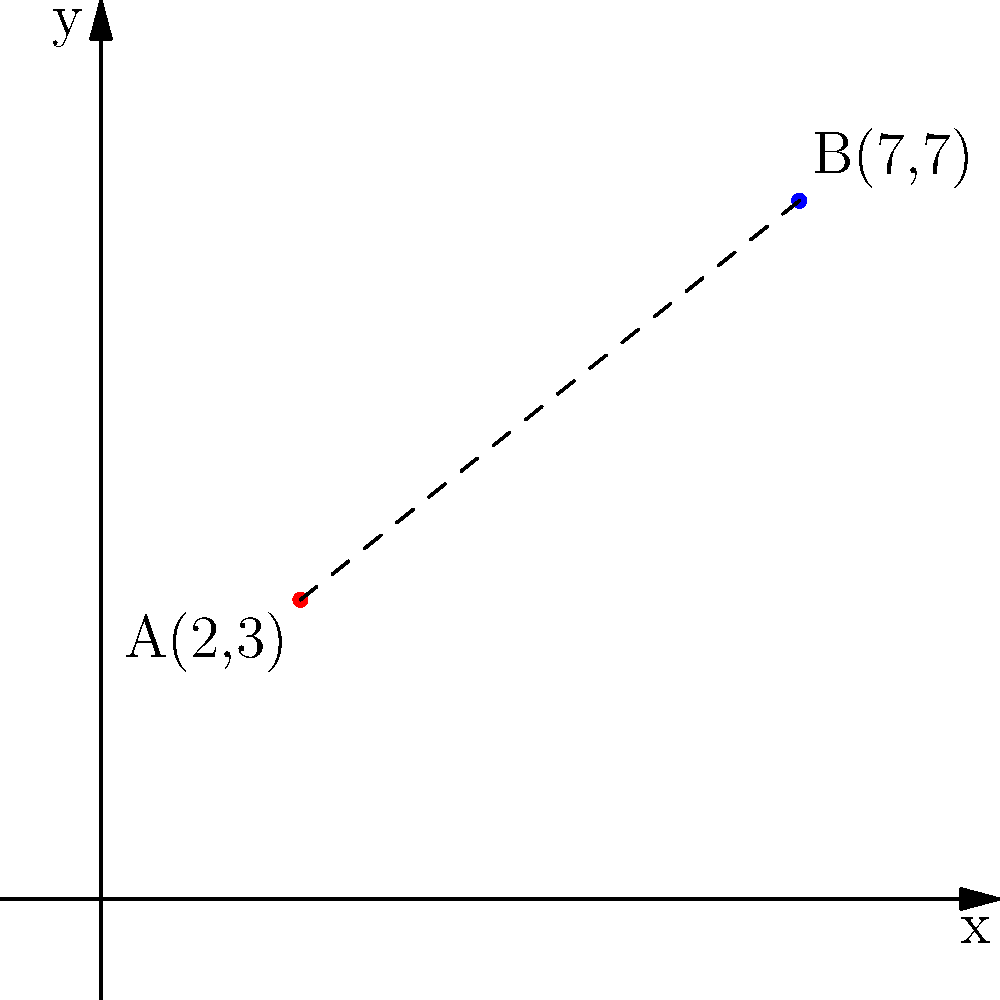In a relationship counseling session, you use a graph to visualize emotional closeness between two partners. Partner A is represented by the point (2,3) and Partner B by the point (7,7) on the graph. Calculate the emotional distance between the partners using the distance formula. Round your answer to two decimal places. To solve this problem, we'll use the distance formula derived from the Pythagorean theorem:

$d = \sqrt{(x_2-x_1)^2 + (y_2-y_1)^2}$

Where $(x_1,y_1)$ represents the coordinates of point A and $(x_2,y_2)$ represents the coordinates of point B.

Step 1: Identify the coordinates
* Point A: $(x_1,y_1) = (2,3)$
* Point B: $(x_2,y_2) = (7,7)$

Step 2: Plug the values into the distance formula
$d = \sqrt{(7-2)^2 + (7-3)^2}$

Step 3: Simplify the expressions inside the parentheses
$d = \sqrt{5^2 + 4^2}$

Step 4: Calculate the squares
$d = \sqrt{25 + 16}$

Step 5: Add the values under the square root
$d = \sqrt{41}$

Step 6: Calculate the square root and round to two decimal places
$d \approx 6.40$

Therefore, the emotional distance between the partners is approximately 6.40 units.
Answer: 6.40 